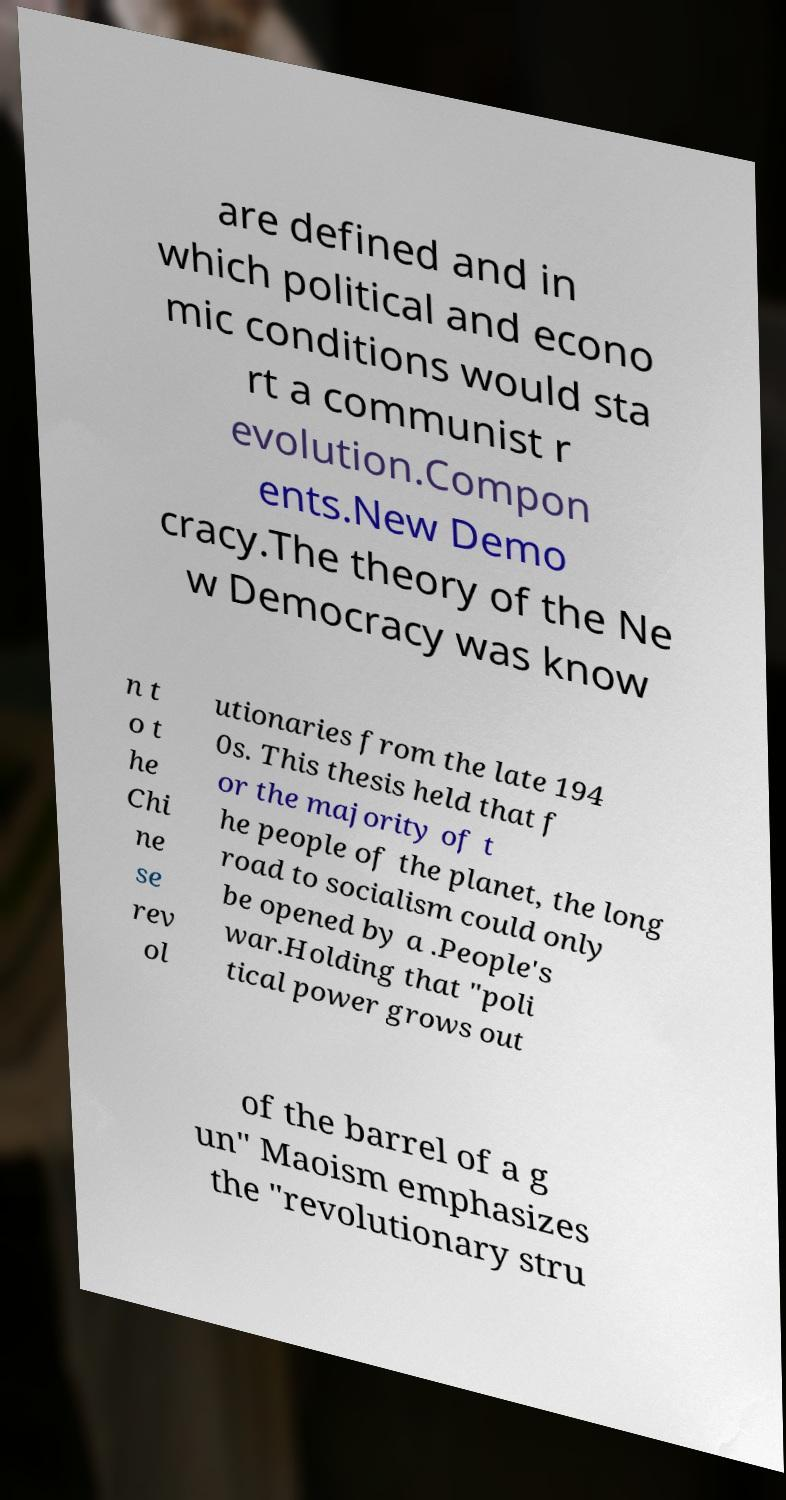What messages or text are displayed in this image? I need them in a readable, typed format. are defined and in which political and econo mic conditions would sta rt a communist r evolution.Compon ents.New Demo cracy.The theory of the Ne w Democracy was know n t o t he Chi ne se rev ol utionaries from the late 194 0s. This thesis held that f or the majority of t he people of the planet, the long road to socialism could only be opened by a .People's war.Holding that "poli tical power grows out of the barrel of a g un" Maoism emphasizes the "revolutionary stru 